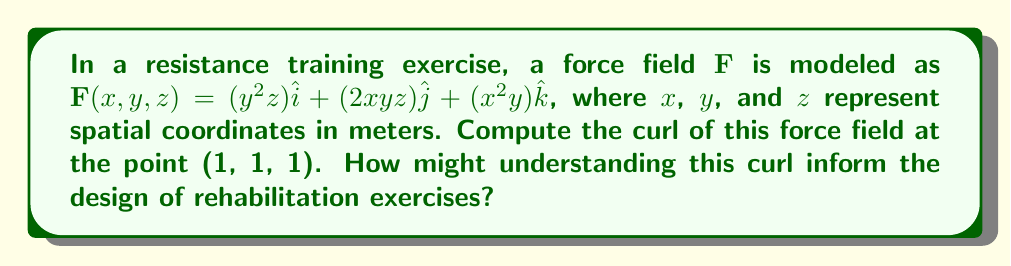Give your solution to this math problem. To compute the curl of the force field $\mathbf{F}$, we need to calculate:

$$\text{curl }\mathbf{F} = \nabla \times \mathbf{F} = \left(\frac{\partial F_z}{\partial y} - \frac{\partial F_y}{\partial z}\right)\hat{i} + \left(\frac{\partial F_x}{\partial z} - \frac{\partial F_z}{\partial x}\right)\hat{j} + \left(\frac{\partial F_y}{\partial x} - \frac{\partial F_x}{\partial y}\right)\hat{k}$$

Step 1: Identify the components of $\mathbf{F}$:
$F_x = y^2z$
$F_y = 2xyz$
$F_z = x^2y$

Step 2: Calculate the partial derivatives:
$\frac{\partial F_z}{\partial y} = x^2$
$\frac{\partial F_y}{\partial z} = 2xy$
$\frac{\partial F_x}{\partial z} = y^2$
$\frac{\partial F_z}{\partial x} = 2xy$
$\frac{\partial F_y}{\partial x} = 2yz$
$\frac{\partial F_x}{\partial y} = 2yz$

Step 3: Substitute these into the curl equation:
$$\text{curl }\mathbf{F} = (x^2 - 2xy)\hat{i} + (y^2 - 2xy)\hat{j} + (2yz - 2yz)\hat{k}$$

Step 4: Simplify:
$$\text{curl }\mathbf{F} = (x^2 - 2xy)\hat{i} + (y^2 - 2xy)\hat{j} + 0\hat{k}$$

Step 5: Evaluate at the point (1, 1, 1):
$$\text{curl }\mathbf{F}(1,1,1) = (1^2 - 2(1)(1))\hat{i} + (1^2 - 2(1)(1))\hat{j} + 0\hat{k} = -1\hat{i} - 1\hat{j} + 0\hat{k}$$

Understanding this curl can inform rehabilitation exercise design by indicating rotational tendencies in the force field. A non-zero curl suggests that the force is not conservative, which may be important for creating balanced, multi-directional resistance exercises that target specific muscle groups or movement patterns.
Answer: $-\hat{i} - \hat{j}$ 